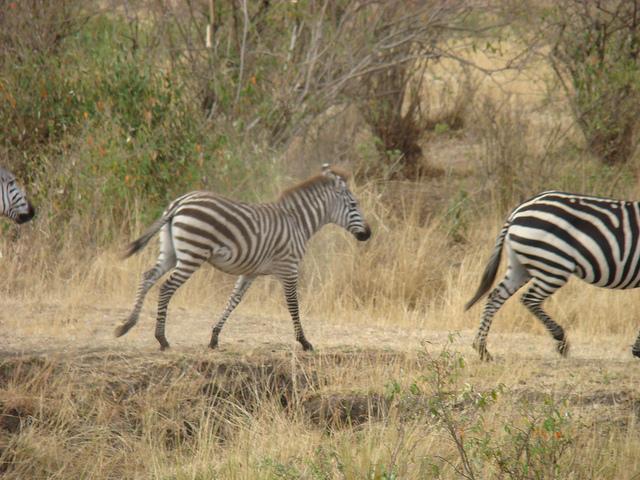How many zebras are there?
Give a very brief answer. 2. How many people are wearing orange vests?
Give a very brief answer. 0. 